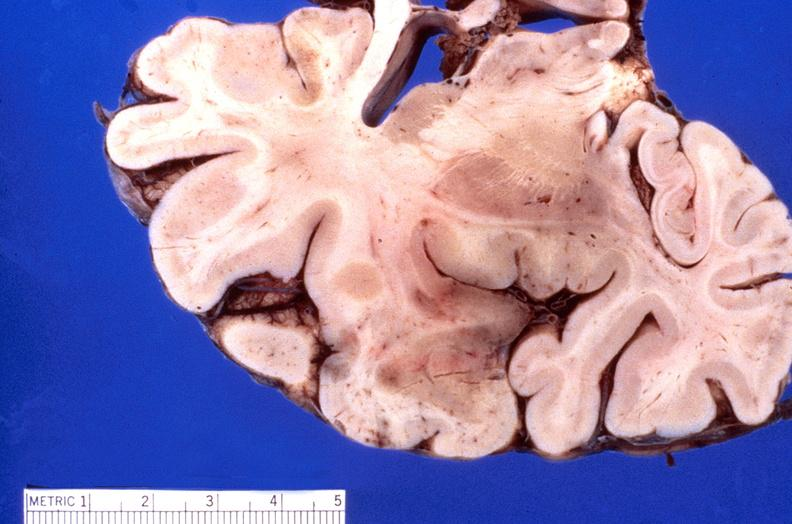does this image show brain, herpes encephalitis?
Answer the question using a single word or phrase. Yes 